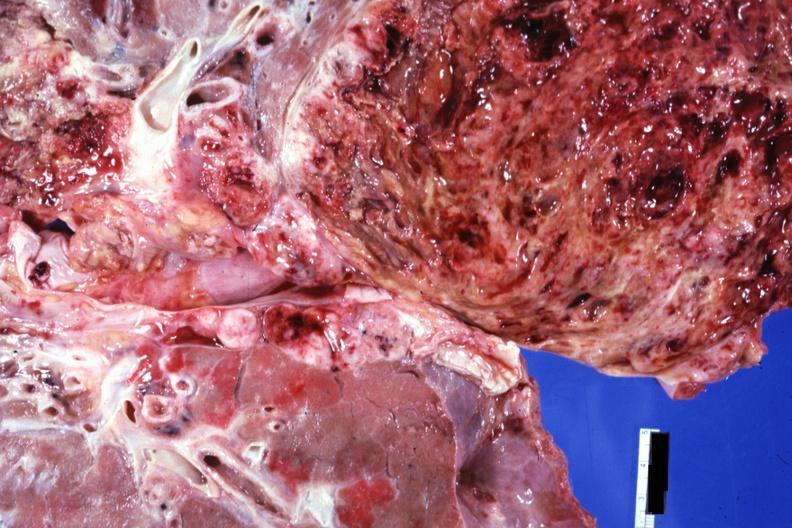s eye present?
Answer the question using a single word or phrase. No 